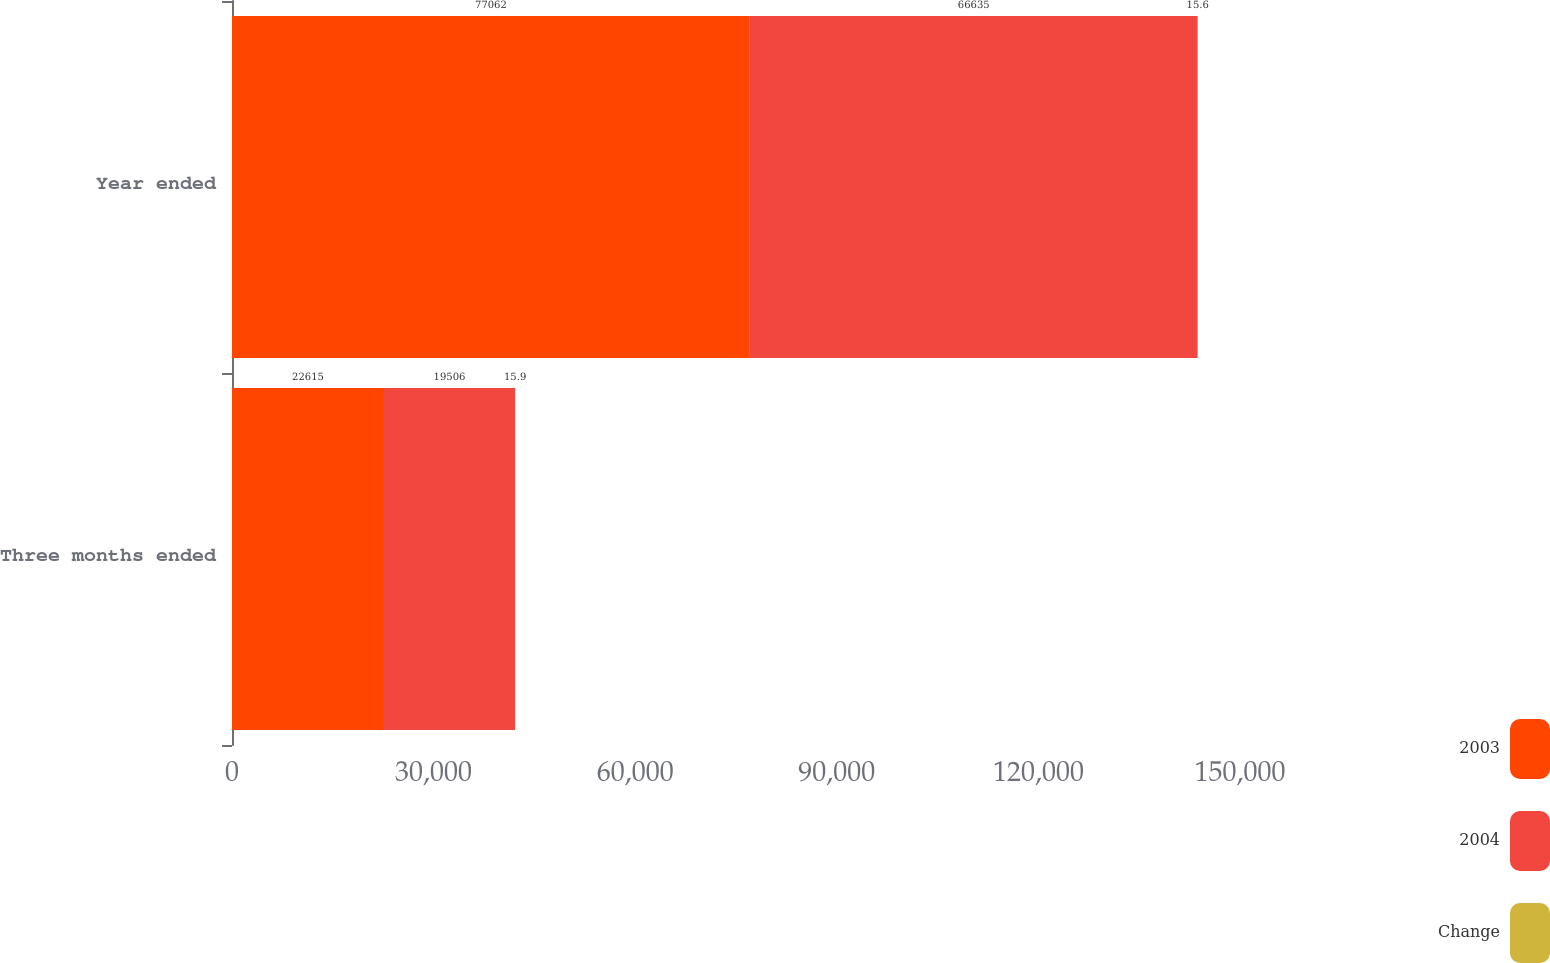Convert chart. <chart><loc_0><loc_0><loc_500><loc_500><stacked_bar_chart><ecel><fcel>Three months ended<fcel>Year ended<nl><fcel>2003<fcel>22615<fcel>77062<nl><fcel>2004<fcel>19506<fcel>66635<nl><fcel>Change<fcel>15.9<fcel>15.6<nl></chart> 